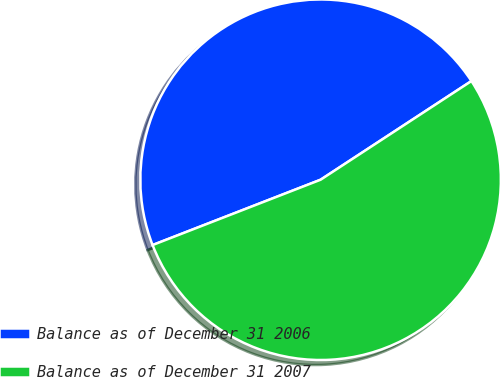<chart> <loc_0><loc_0><loc_500><loc_500><pie_chart><fcel>Balance as of December 31 2006<fcel>Balance as of December 31 2007<nl><fcel>46.68%<fcel>53.32%<nl></chart> 